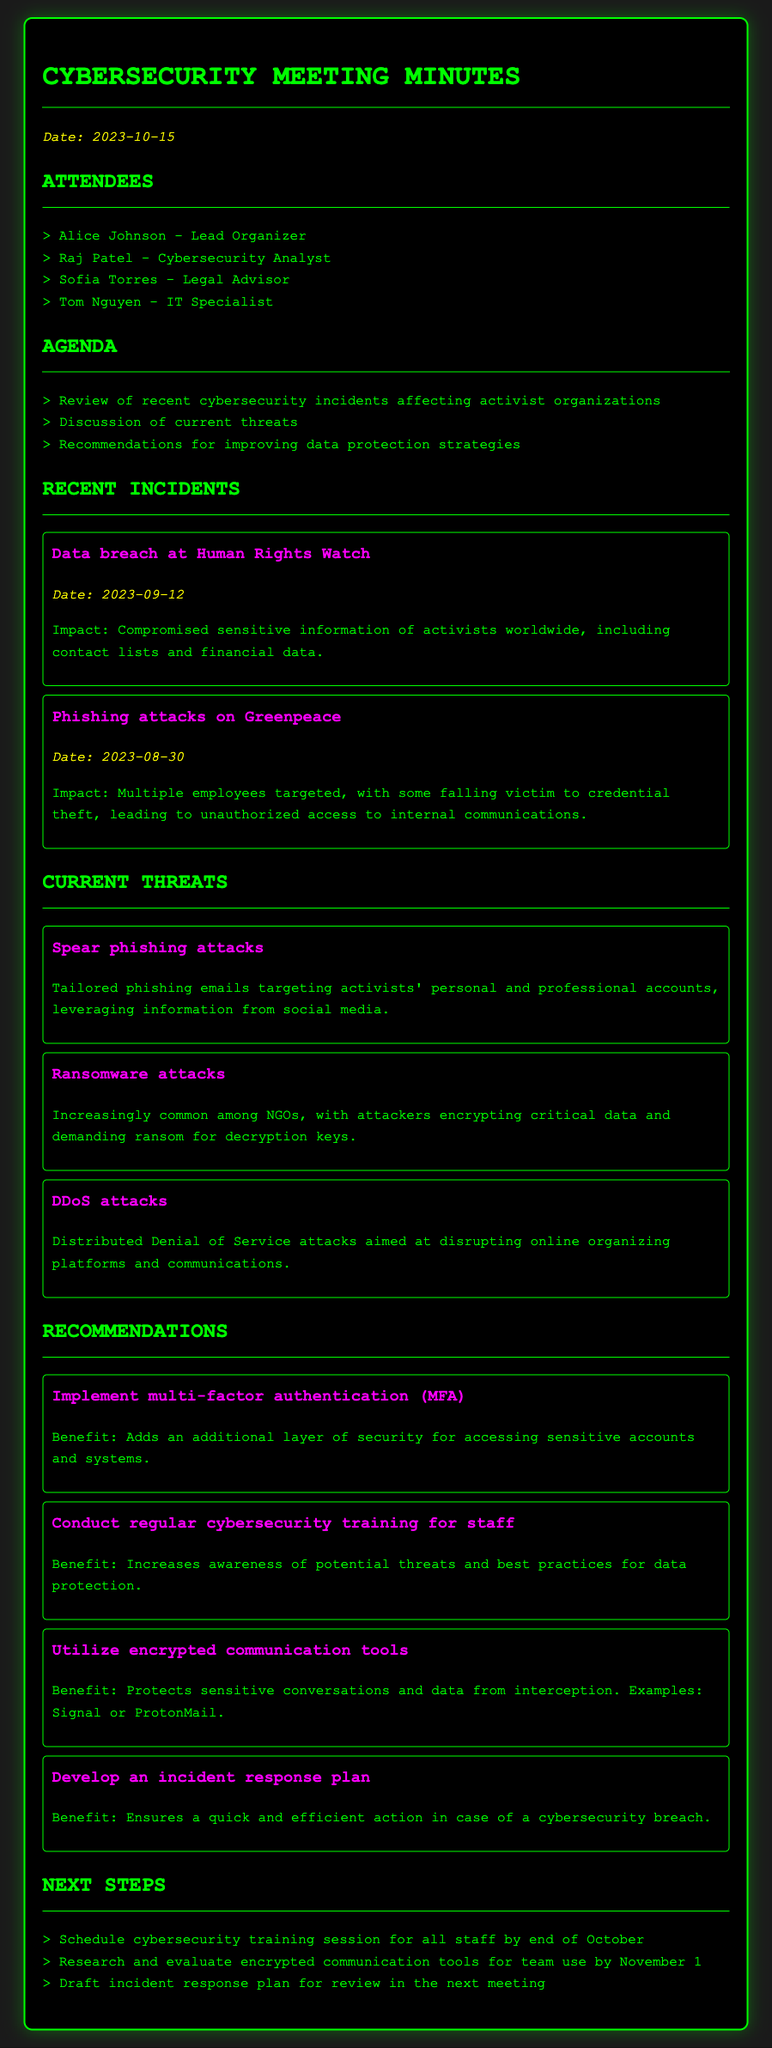Who are the attendees of the meeting? The attendees' names and roles are listed in the document under the Attendees section.
Answer: Alice Johnson, Raj Patel, Sofia Torres, Tom Nguyen What was the date of the Human Rights Watch data breach? The date is specified within the Recent Incidents section for each listed incident.
Answer: 2023-09-12 What type of attack was aimed at Greenpeace? The specific incident mentions the type of attack that was conducted on Greenpeace.
Answer: Phishing attacks Name one current threat discussed in the meeting. The Current Threats section lists various threats, any of which can be an acceptable answer.
Answer: Ransomware attacks What is one recommended strategy to improve data protection? Recommendations for improving data protection are provided, and selecting any of these is valid.
Answer: Implement multi-factor authentication (MFA) How many incidents were reviewed in the meeting? The number of incidents can be counted from the Recent Incidents section.
Answer: 2 What is the benefit of utilizing encrypted communication tools? Each recommendation includes its benefit, specifically mentioned in the Recommendations section.
Answer: Protects sensitive conversations and data from interception What is one of the next steps mentioned in the document? The Next Steps section outlines future actions to be taken after the meeting.
Answer: Schedule cybersecurity training session for all staff by end of October 